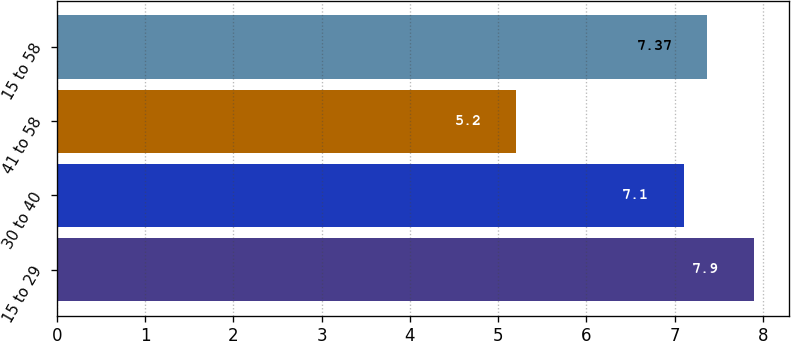Convert chart. <chart><loc_0><loc_0><loc_500><loc_500><bar_chart><fcel>15 to 29<fcel>30 to 40<fcel>41 to 58<fcel>15 to 58<nl><fcel>7.9<fcel>7.1<fcel>5.2<fcel>7.37<nl></chart> 